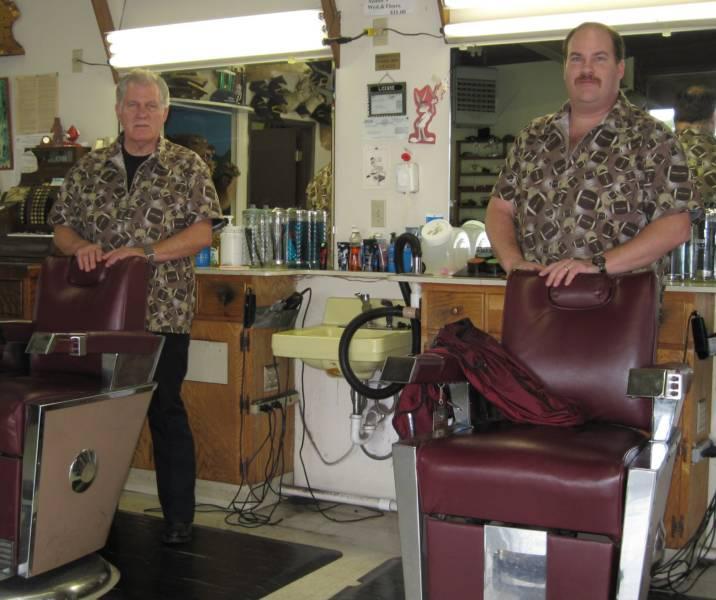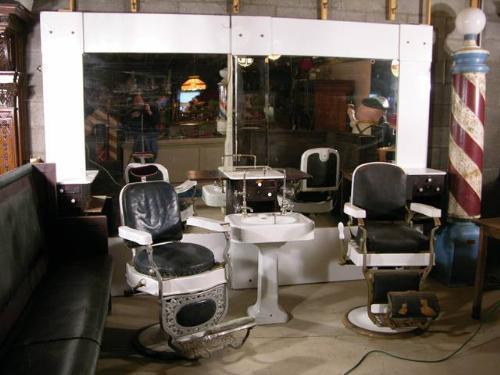The first image is the image on the left, the second image is the image on the right. For the images shown, is this caption "There are more than eleven frames on the wall in one of the images." true? Answer yes or no. No. 